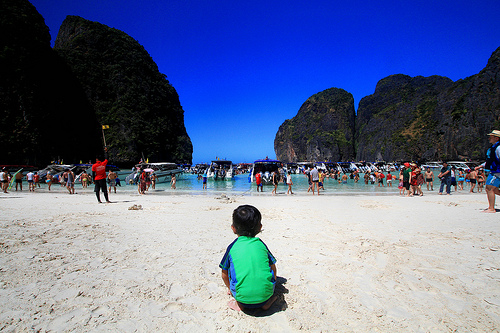<image>
Can you confirm if the boy is on the sand? Yes. Looking at the image, I can see the boy is positioned on top of the sand, with the sand providing support. 